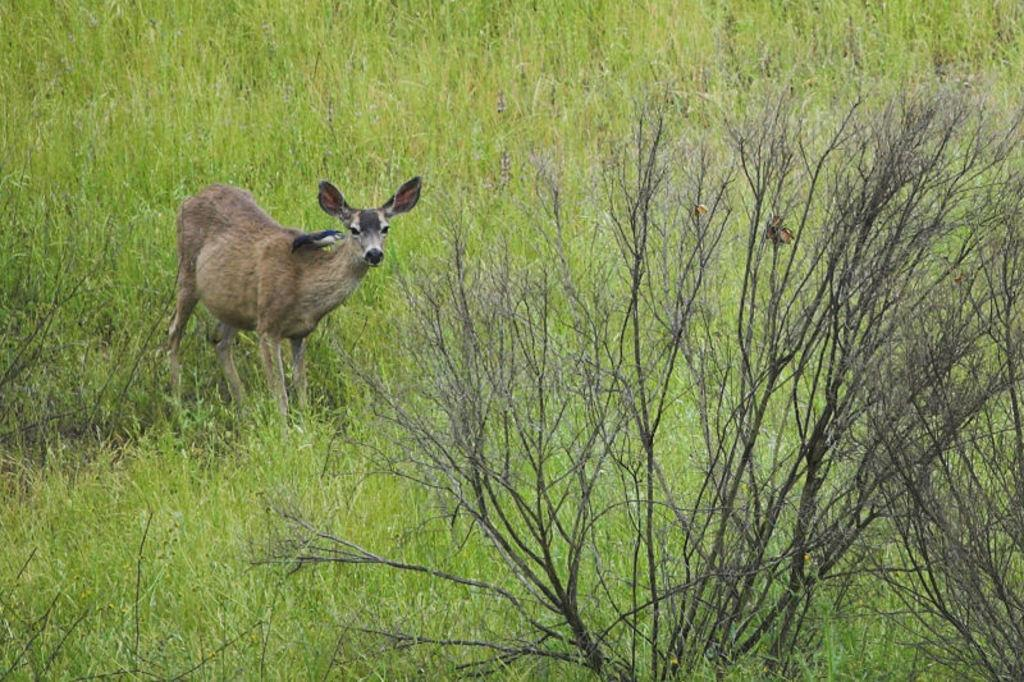What type of creature is in the image? There is an animal in the image. What is the animal standing on? The animal is standing on the grass. Can you describe the coloring of the animal? The animal has brown and black coloring. What is in front of the animal? There are dried plants in front of the animal. What type of plane can be seen flying over the animal in the image? There is no plane visible in the image; it only features an animal standing on the grass with dried plants in front of it. 